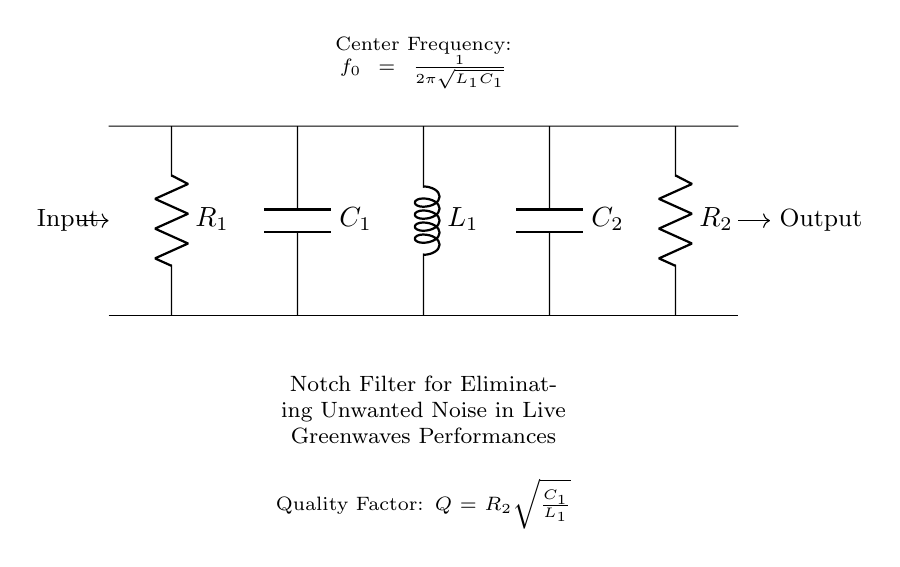What does R1 represent in the circuit? R1 is a resistor and it is part of the notch filter design. It primarily impacts the filter's behavior and is located at the left side of the circuit diagram.
Answer: Resistor What is the function of C2 in this circuit? C2 is a capacitor that, in conjunction with other components, helps to determine the filtering characteristics of the notch filter. It is connected to the output section of the circuit.
Answer: Capacitor What is the center frequency of this notch filter? The center frequency can be calculated using the formula provided in the circuit diagram: f0 = 1/(2π√(L1C1)). This shows the frequency at which the filter attenuates signals.
Answer: 1/(2π√(L1C1)) How is the quality factor Q determined in this circuit? The quality factor Q is defined by the formula Q = R2√(C1/L1). This represents the selectivity of the notch filter and helps to assess how sharply it can filter frequencies around the center frequency.
Answer: R2√(C1/L1) What type of filter is represented in this circuit? The circuit represents a notch filter, which is specifically designed to eliminate unwanted noise at a particular frequency while allowing other frequencies to pass through.
Answer: Notch filter 